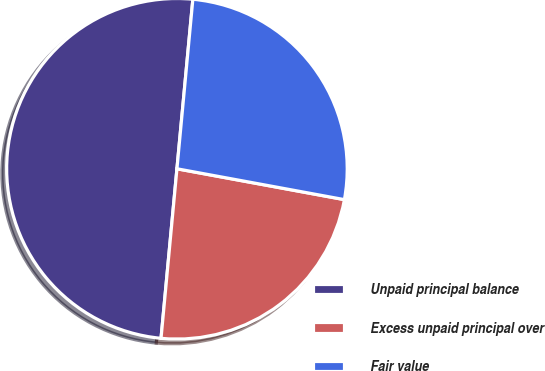Convert chart. <chart><loc_0><loc_0><loc_500><loc_500><pie_chart><fcel>Unpaid principal balance<fcel>Excess unpaid principal over<fcel>Fair value<nl><fcel>50.0%<fcel>23.59%<fcel>26.41%<nl></chart> 